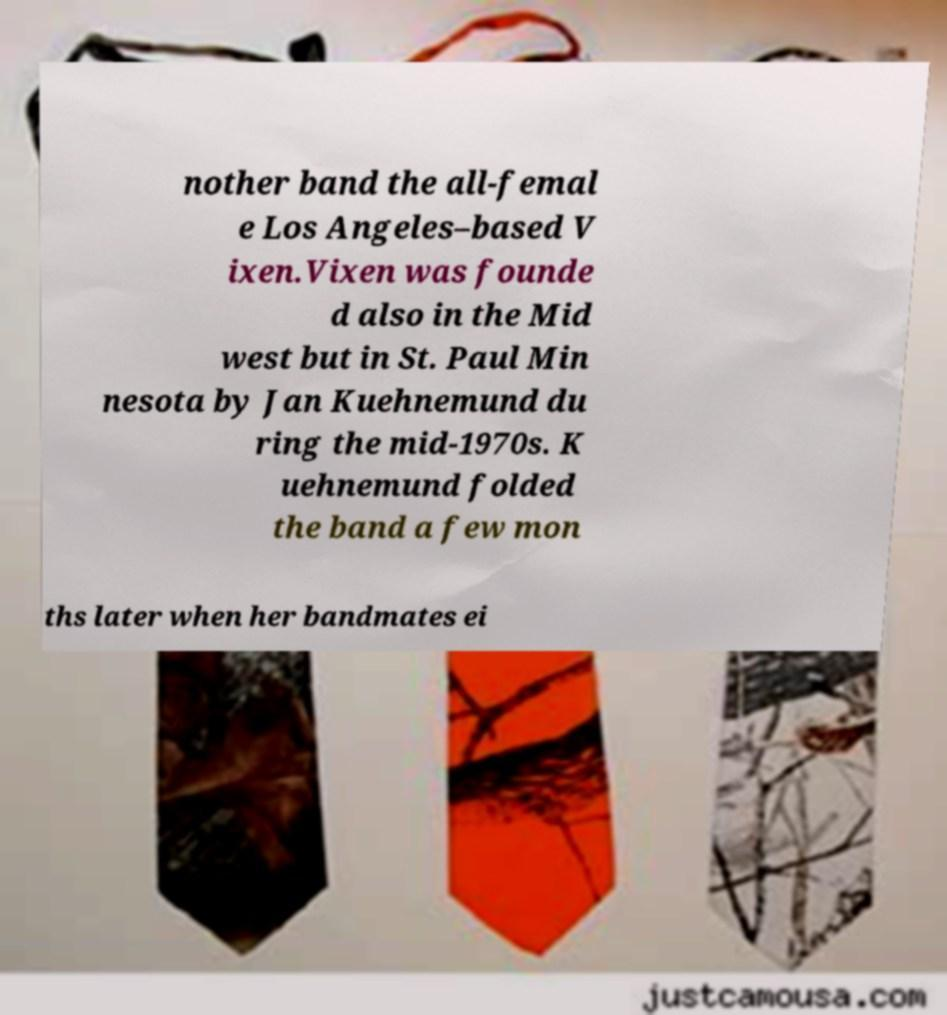Can you accurately transcribe the text from the provided image for me? nother band the all-femal e Los Angeles–based V ixen.Vixen was founde d also in the Mid west but in St. Paul Min nesota by Jan Kuehnemund du ring the mid-1970s. K uehnemund folded the band a few mon ths later when her bandmates ei 